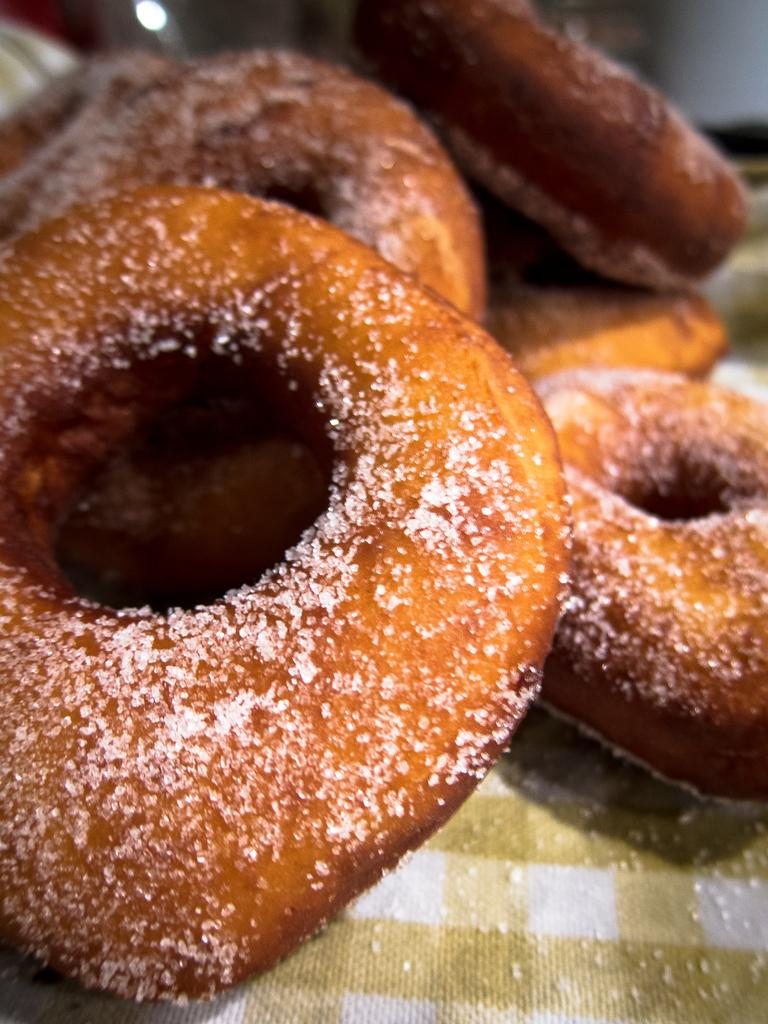What is placed on the cloth in the image? There is food on a cloth in the image. Can you identify any specific ingredient or condiment in the image? Yes, there is sugar in the image. What type of ornament is hanging from the tiger's neck in the image? There is no tiger or ornament present in the image. Can you describe the chess pieces on the table in the image? There is no mention of chess or a table in the provided facts, so we cannot describe any chess pieces. 